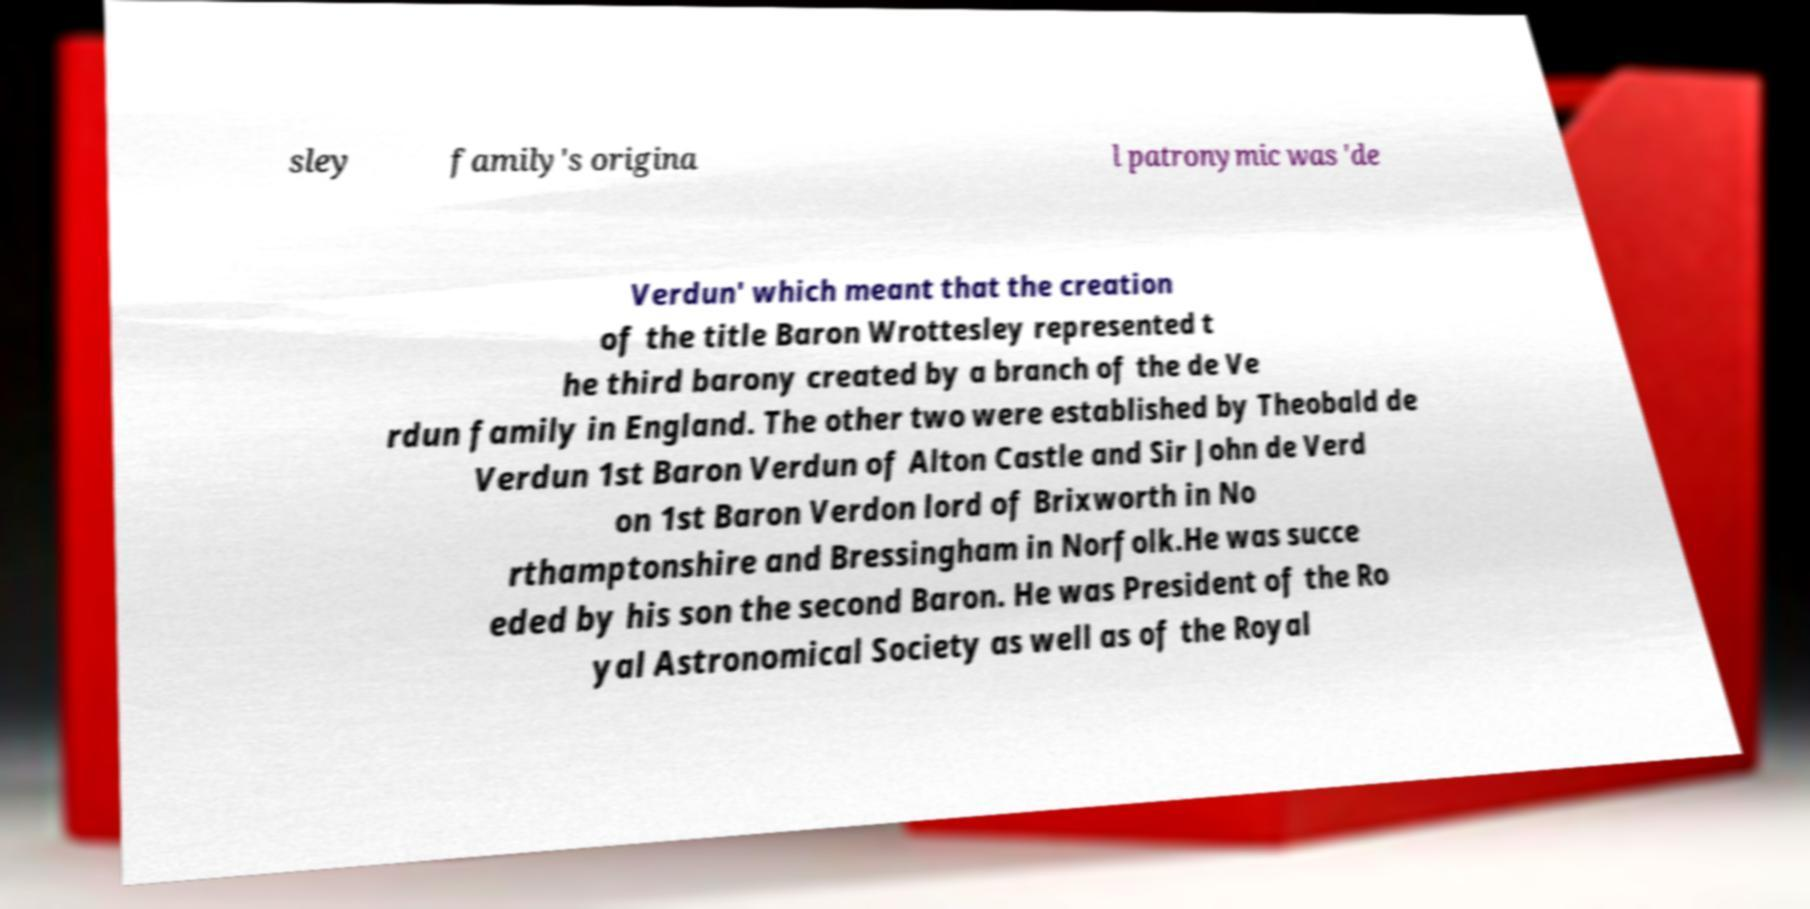Please read and relay the text visible in this image. What does it say? sley family's origina l patronymic was 'de Verdun' which meant that the creation of the title Baron Wrottesley represented t he third barony created by a branch of the de Ve rdun family in England. The other two were established by Theobald de Verdun 1st Baron Verdun of Alton Castle and Sir John de Verd on 1st Baron Verdon lord of Brixworth in No rthamptonshire and Bressingham in Norfolk.He was succe eded by his son the second Baron. He was President of the Ro yal Astronomical Society as well as of the Royal 